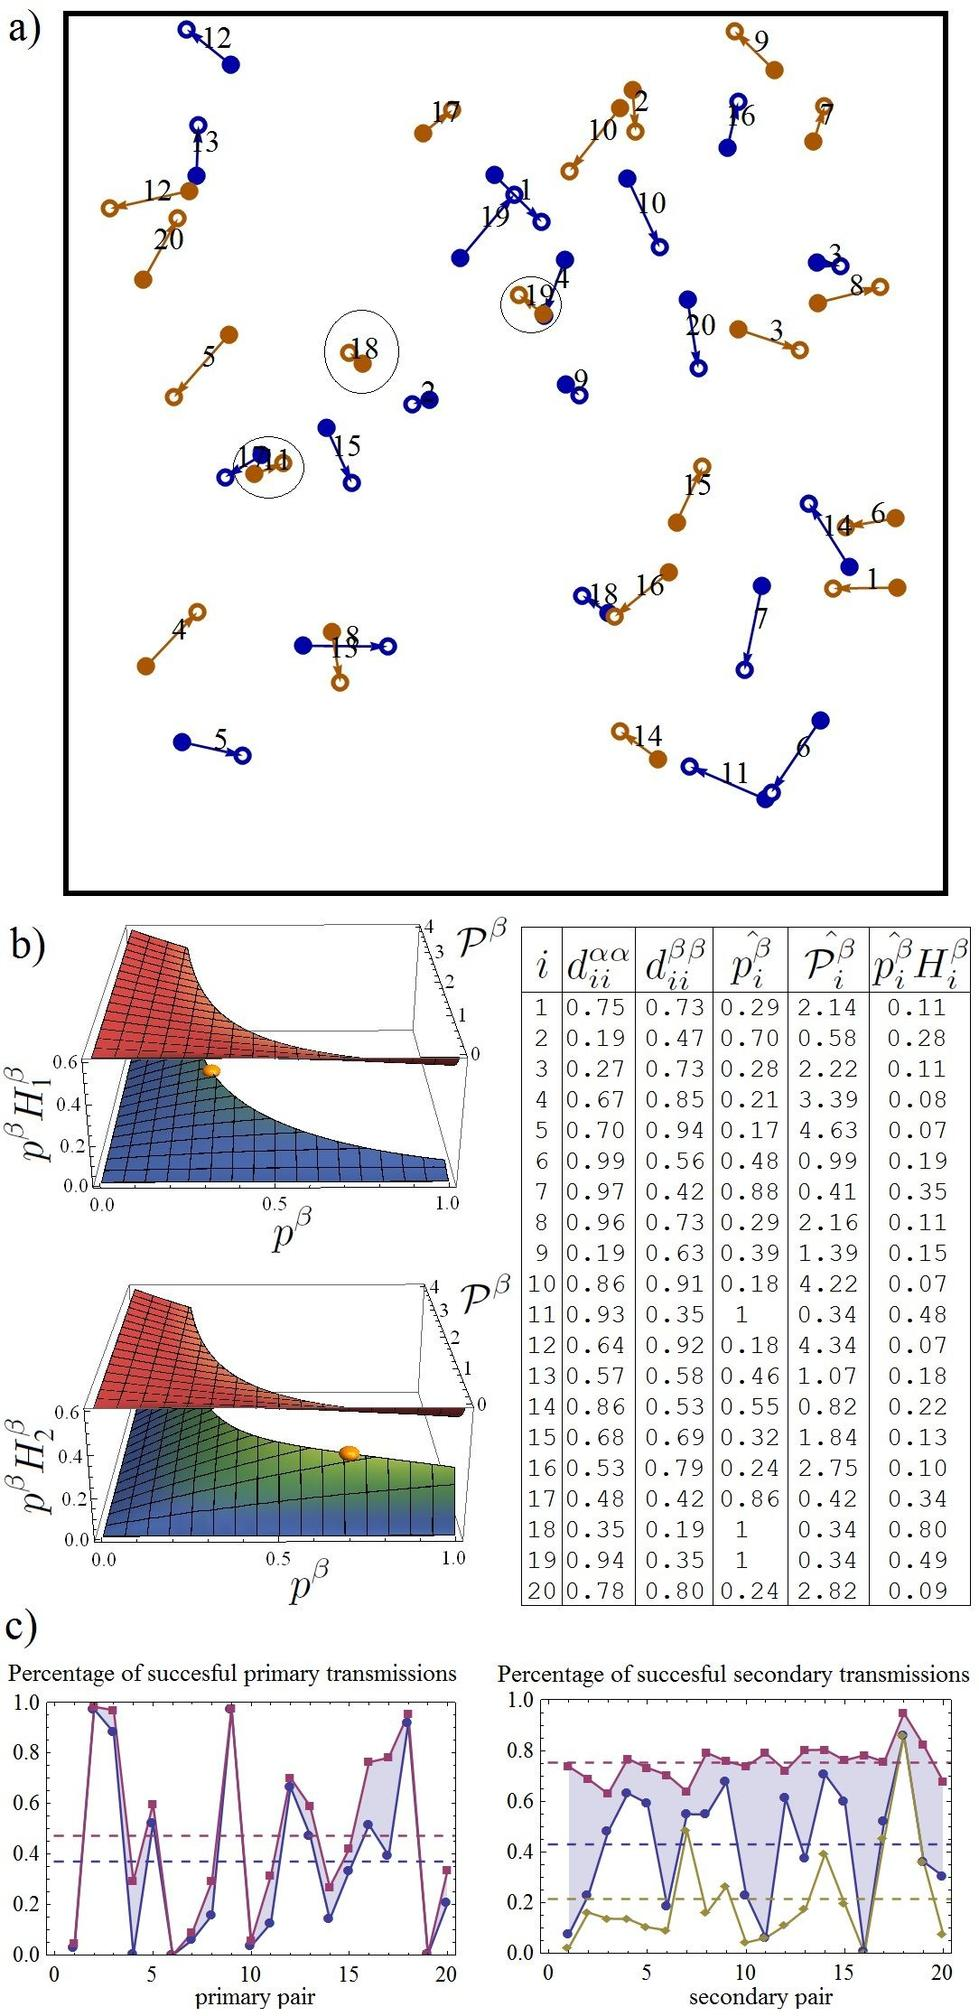What does the highlighted loop involving nodes Q15 and Q18 in figure a) suggest about their interaction? A) They have no interaction between them. B) They have a direct interaction with each other. C) They are part of a larger network but do not directly interact. D) They are completely isolated from the network. The highlighted loop connecting nodes Q15 and Q18 in figure a) clearly indicates a direct interaction between these nodes. This type of visual representation often suggests that the nodes not only communicate but may have specific dynamics or functions within the network that require direct connectivity. Therefore, the most accurate answer is Option B, indicating that they directly interact with each other. This understanding is crucial for correctly interpreting network diagrams where direct connections represent the flow of information or interaction between entities. 